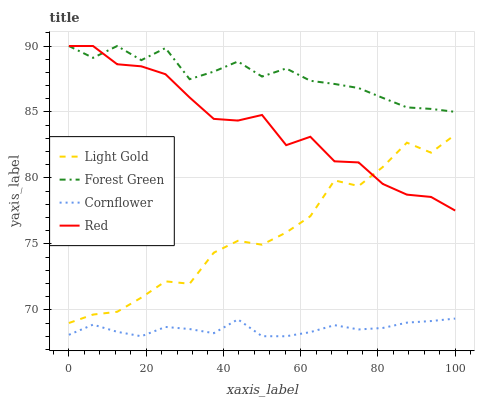Does Cornflower have the minimum area under the curve?
Answer yes or no. Yes. Does Forest Green have the maximum area under the curve?
Answer yes or no. Yes. Does Light Gold have the minimum area under the curve?
Answer yes or no. No. Does Light Gold have the maximum area under the curve?
Answer yes or no. No. Is Cornflower the smoothest?
Answer yes or no. Yes. Is Light Gold the roughest?
Answer yes or no. Yes. Is Forest Green the smoothest?
Answer yes or no. No. Is Forest Green the roughest?
Answer yes or no. No. Does Cornflower have the lowest value?
Answer yes or no. Yes. Does Light Gold have the lowest value?
Answer yes or no. No. Does Red have the highest value?
Answer yes or no. Yes. Does Light Gold have the highest value?
Answer yes or no. No. Is Light Gold less than Forest Green?
Answer yes or no. Yes. Is Red greater than Cornflower?
Answer yes or no. Yes. Does Forest Green intersect Red?
Answer yes or no. Yes. Is Forest Green less than Red?
Answer yes or no. No. Is Forest Green greater than Red?
Answer yes or no. No. Does Light Gold intersect Forest Green?
Answer yes or no. No. 